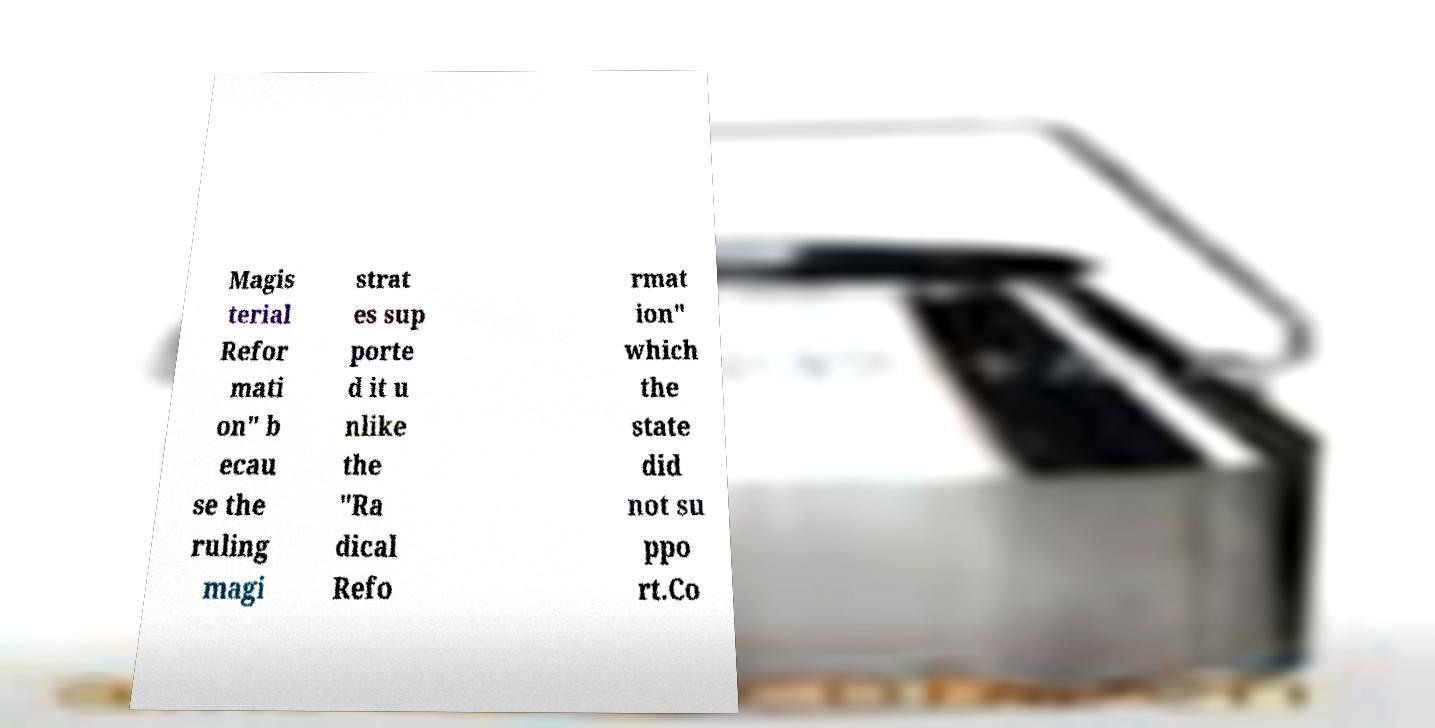Please read and relay the text visible in this image. What does it say? Magis terial Refor mati on" b ecau se the ruling magi strat es sup porte d it u nlike the "Ra dical Refo rmat ion" which the state did not su ppo rt.Co 